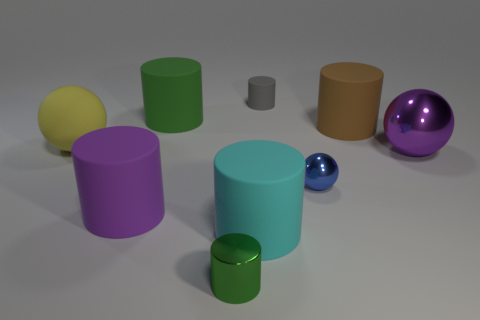Is the number of gray rubber objects in front of the purple ball less than the number of matte cylinders?
Provide a succinct answer. Yes. What is the color of the cylinder that is left of the green thing behind the small blue thing that is in front of the tiny rubber cylinder?
Your response must be concise. Purple. What number of rubber objects are small blue things or small cylinders?
Provide a succinct answer. 1. Is the blue metallic ball the same size as the yellow object?
Provide a short and direct response. No. Is the number of tiny metal spheres that are left of the small rubber cylinder less than the number of purple balls left of the small blue metal ball?
Make the answer very short. No. The green metallic object is what size?
Your answer should be compact. Small. What number of big objects are either purple cylinders or yellow matte things?
Your response must be concise. 2. Does the green matte cylinder have the same size as the green object in front of the green matte cylinder?
Provide a succinct answer. No. Is there any other thing that is the same shape as the small blue metallic thing?
Give a very brief answer. Yes. What number of tiny gray rubber balls are there?
Provide a succinct answer. 0. 